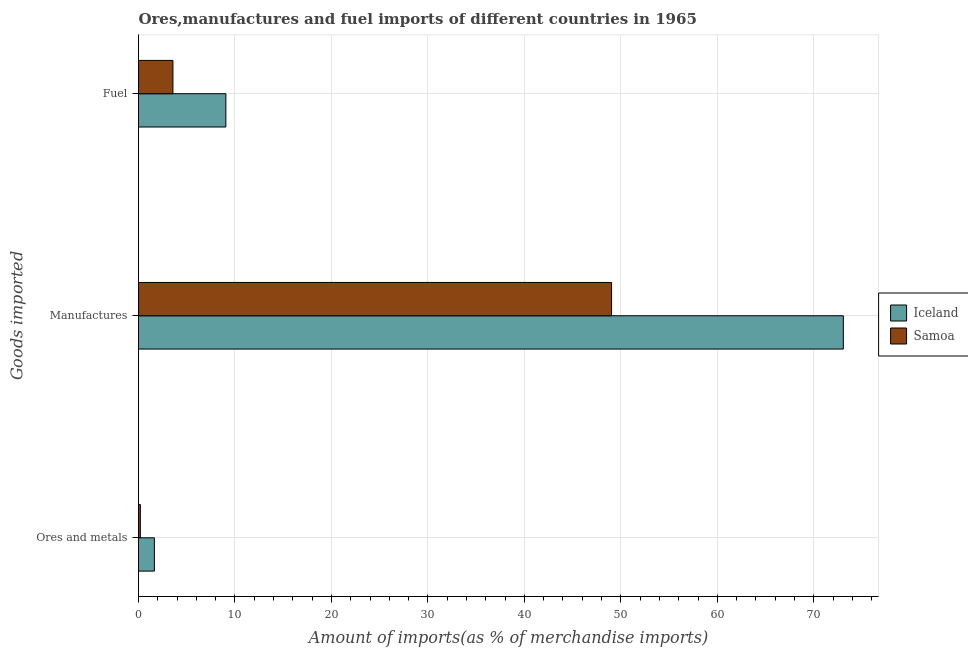How many groups of bars are there?
Offer a terse response. 3. How many bars are there on the 1st tick from the top?
Offer a very short reply. 2. What is the label of the 1st group of bars from the top?
Offer a very short reply. Fuel. What is the percentage of fuel imports in Samoa?
Your answer should be very brief. 3.57. Across all countries, what is the maximum percentage of ores and metals imports?
Make the answer very short. 1.64. Across all countries, what is the minimum percentage of ores and metals imports?
Your answer should be very brief. 0.19. In which country was the percentage of manufactures imports minimum?
Your answer should be compact. Samoa. What is the total percentage of manufactures imports in the graph?
Offer a terse response. 122.11. What is the difference between the percentage of fuel imports in Samoa and that in Iceland?
Your answer should be very brief. -5.49. What is the difference between the percentage of ores and metals imports in Samoa and the percentage of manufactures imports in Iceland?
Ensure brevity in your answer.  -72.88. What is the average percentage of fuel imports per country?
Keep it short and to the point. 6.31. What is the difference between the percentage of manufactures imports and percentage of ores and metals imports in Samoa?
Provide a short and direct response. 48.85. What is the ratio of the percentage of ores and metals imports in Samoa to that in Iceland?
Provide a succinct answer. 0.12. Is the percentage of fuel imports in Iceland less than that in Samoa?
Make the answer very short. No. What is the difference between the highest and the second highest percentage of ores and metals imports?
Offer a very short reply. 1.45. What is the difference between the highest and the lowest percentage of ores and metals imports?
Your response must be concise. 1.45. Is the sum of the percentage of fuel imports in Iceland and Samoa greater than the maximum percentage of ores and metals imports across all countries?
Your answer should be compact. Yes. What does the 2nd bar from the bottom in Ores and metals represents?
Your answer should be compact. Samoa. How many bars are there?
Give a very brief answer. 6. How many countries are there in the graph?
Make the answer very short. 2. What is the difference between two consecutive major ticks on the X-axis?
Keep it short and to the point. 10. Does the graph contain grids?
Your response must be concise. Yes. How are the legend labels stacked?
Give a very brief answer. Vertical. What is the title of the graph?
Give a very brief answer. Ores,manufactures and fuel imports of different countries in 1965. What is the label or title of the X-axis?
Keep it short and to the point. Amount of imports(as % of merchandise imports). What is the label or title of the Y-axis?
Provide a succinct answer. Goods imported. What is the Amount of imports(as % of merchandise imports) of Iceland in Ores and metals?
Your answer should be compact. 1.64. What is the Amount of imports(as % of merchandise imports) in Samoa in Ores and metals?
Ensure brevity in your answer.  0.19. What is the Amount of imports(as % of merchandise imports) of Iceland in Manufactures?
Your answer should be very brief. 73.07. What is the Amount of imports(as % of merchandise imports) in Samoa in Manufactures?
Make the answer very short. 49.04. What is the Amount of imports(as % of merchandise imports) in Iceland in Fuel?
Your response must be concise. 9.06. What is the Amount of imports(as % of merchandise imports) of Samoa in Fuel?
Your answer should be very brief. 3.57. Across all Goods imported, what is the maximum Amount of imports(as % of merchandise imports) of Iceland?
Keep it short and to the point. 73.07. Across all Goods imported, what is the maximum Amount of imports(as % of merchandise imports) of Samoa?
Keep it short and to the point. 49.04. Across all Goods imported, what is the minimum Amount of imports(as % of merchandise imports) in Iceland?
Keep it short and to the point. 1.64. Across all Goods imported, what is the minimum Amount of imports(as % of merchandise imports) of Samoa?
Provide a succinct answer. 0.19. What is the total Amount of imports(as % of merchandise imports) in Iceland in the graph?
Your answer should be compact. 83.77. What is the total Amount of imports(as % of merchandise imports) of Samoa in the graph?
Offer a very short reply. 52.8. What is the difference between the Amount of imports(as % of merchandise imports) of Iceland in Ores and metals and that in Manufactures?
Offer a very short reply. -71.42. What is the difference between the Amount of imports(as % of merchandise imports) of Samoa in Ores and metals and that in Manufactures?
Provide a succinct answer. -48.85. What is the difference between the Amount of imports(as % of merchandise imports) of Iceland in Ores and metals and that in Fuel?
Ensure brevity in your answer.  -7.41. What is the difference between the Amount of imports(as % of merchandise imports) of Samoa in Ores and metals and that in Fuel?
Provide a short and direct response. -3.38. What is the difference between the Amount of imports(as % of merchandise imports) of Iceland in Manufactures and that in Fuel?
Make the answer very short. 64.01. What is the difference between the Amount of imports(as % of merchandise imports) in Samoa in Manufactures and that in Fuel?
Give a very brief answer. 45.47. What is the difference between the Amount of imports(as % of merchandise imports) of Iceland in Ores and metals and the Amount of imports(as % of merchandise imports) of Samoa in Manufactures?
Offer a terse response. -47.4. What is the difference between the Amount of imports(as % of merchandise imports) of Iceland in Ores and metals and the Amount of imports(as % of merchandise imports) of Samoa in Fuel?
Your answer should be very brief. -1.92. What is the difference between the Amount of imports(as % of merchandise imports) of Iceland in Manufactures and the Amount of imports(as % of merchandise imports) of Samoa in Fuel?
Give a very brief answer. 69.5. What is the average Amount of imports(as % of merchandise imports) of Iceland per Goods imported?
Keep it short and to the point. 27.92. What is the average Amount of imports(as % of merchandise imports) in Samoa per Goods imported?
Provide a short and direct response. 17.6. What is the difference between the Amount of imports(as % of merchandise imports) in Iceland and Amount of imports(as % of merchandise imports) in Samoa in Ores and metals?
Give a very brief answer. 1.45. What is the difference between the Amount of imports(as % of merchandise imports) of Iceland and Amount of imports(as % of merchandise imports) of Samoa in Manufactures?
Ensure brevity in your answer.  24.03. What is the difference between the Amount of imports(as % of merchandise imports) in Iceland and Amount of imports(as % of merchandise imports) in Samoa in Fuel?
Ensure brevity in your answer.  5.49. What is the ratio of the Amount of imports(as % of merchandise imports) in Iceland in Ores and metals to that in Manufactures?
Your response must be concise. 0.02. What is the ratio of the Amount of imports(as % of merchandise imports) in Samoa in Ores and metals to that in Manufactures?
Your answer should be compact. 0. What is the ratio of the Amount of imports(as % of merchandise imports) of Iceland in Ores and metals to that in Fuel?
Make the answer very short. 0.18. What is the ratio of the Amount of imports(as % of merchandise imports) of Samoa in Ores and metals to that in Fuel?
Offer a terse response. 0.05. What is the ratio of the Amount of imports(as % of merchandise imports) in Iceland in Manufactures to that in Fuel?
Your answer should be compact. 8.07. What is the ratio of the Amount of imports(as % of merchandise imports) of Samoa in Manufactures to that in Fuel?
Offer a very short reply. 13.74. What is the difference between the highest and the second highest Amount of imports(as % of merchandise imports) in Iceland?
Your answer should be compact. 64.01. What is the difference between the highest and the second highest Amount of imports(as % of merchandise imports) of Samoa?
Provide a short and direct response. 45.47. What is the difference between the highest and the lowest Amount of imports(as % of merchandise imports) in Iceland?
Your answer should be compact. 71.42. What is the difference between the highest and the lowest Amount of imports(as % of merchandise imports) in Samoa?
Ensure brevity in your answer.  48.85. 